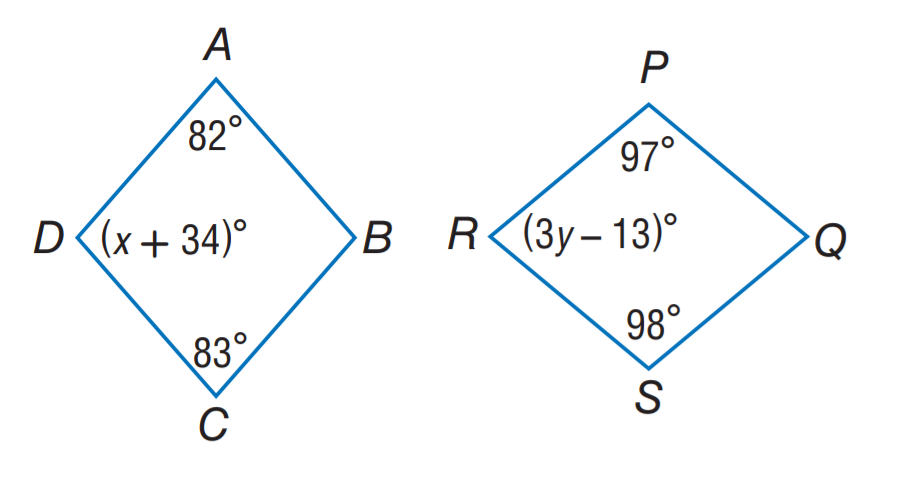Answer the mathemtical geometry problem and directly provide the correct option letter.
Question: A B C D \sim Q S R P. Find y.
Choices: A: 13 B: 32 C: 34 D: 39 B 